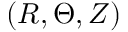<formula> <loc_0><loc_0><loc_500><loc_500>( R , \Theta , Z )</formula> 